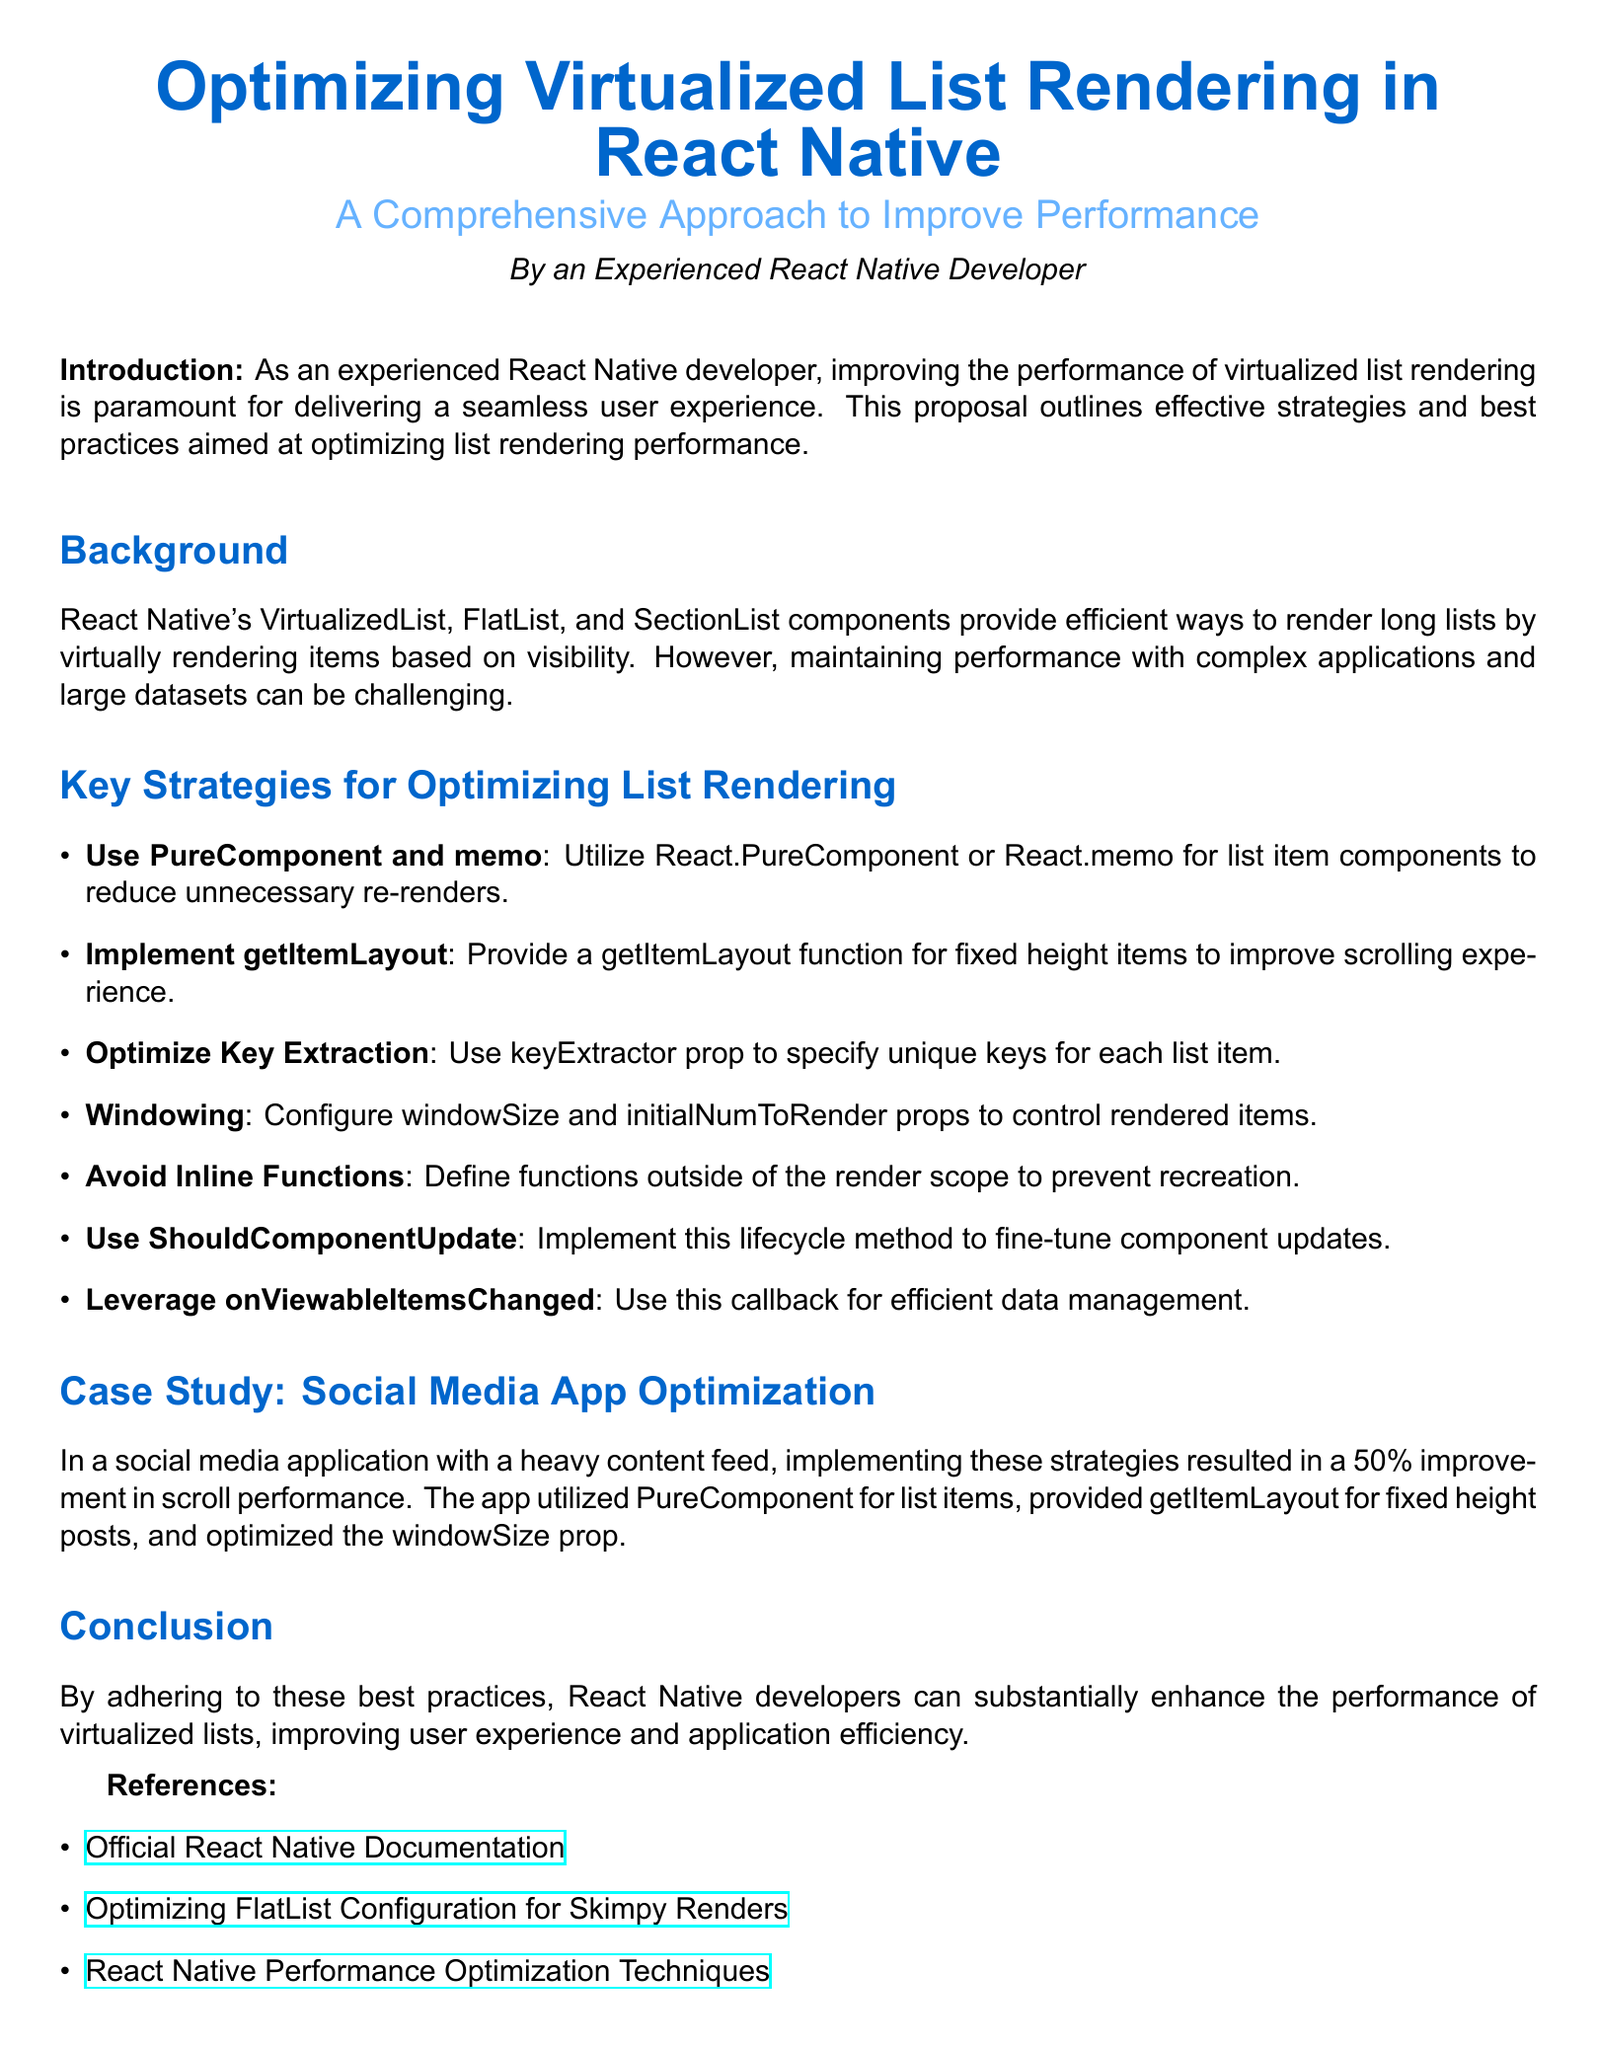What is the title of the proposal? The title is prominently displayed at the top of the document and is "Optimizing Virtualized List Rendering in React Native".
Answer: Optimizing Virtualized List Rendering in React Native Who is the author of the proposal? The document specifies the author at the end of the title section as "an Experienced React Native Developer".
Answer: an Experienced React Native Developer What is one of the key strategies for optimizing list rendering mentioned? The document lists strategies under the "Key Strategies for Optimizing List Rendering" section, such as "Use PureComponent and memo".
Answer: Use PureComponent and memo What percentage improvement in scroll performance was reported in the case study? The case study mentions a specific improvement in performance, stating a "50% improvement in scroll performance".
Answer: 50% What is the purpose of the getItemLayout function? The proposal outlines that providing a getItemLayout function improves the scrolling experience for lists with fixed height items.
Answer: Improve scrolling experience What callback can be leveraged for efficient data management according to the document? The document mentions leveraging "onViewableItemsChanged" for efficient data management.
Answer: onViewableItemsChanged What section details effective strategies and best practices? The section titled "Key Strategies for Optimizing List Rendering" details the effective strategies and best practices for performance improvement.
Answer: Key Strategies for Optimizing List Rendering Where can the official React Native Documentation be found? The references section provides a link for further reading, stating "Official React Native Documentation".
Answer: Official React Native Documentation 